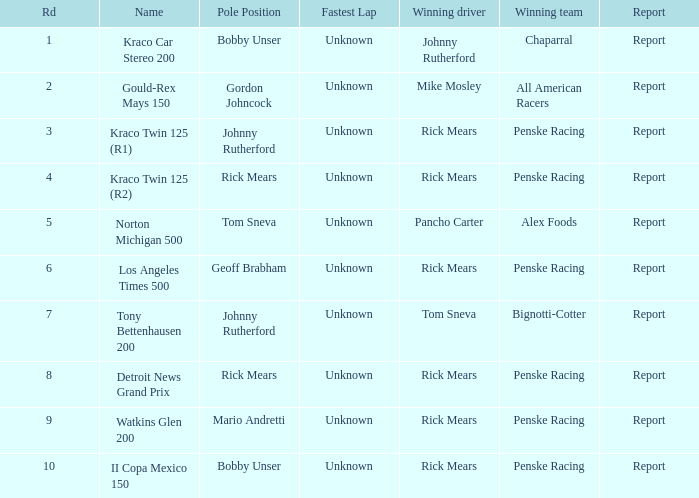In the kraco twin 125 (r2) race, how many triumphant drivers were there? 1.0. 